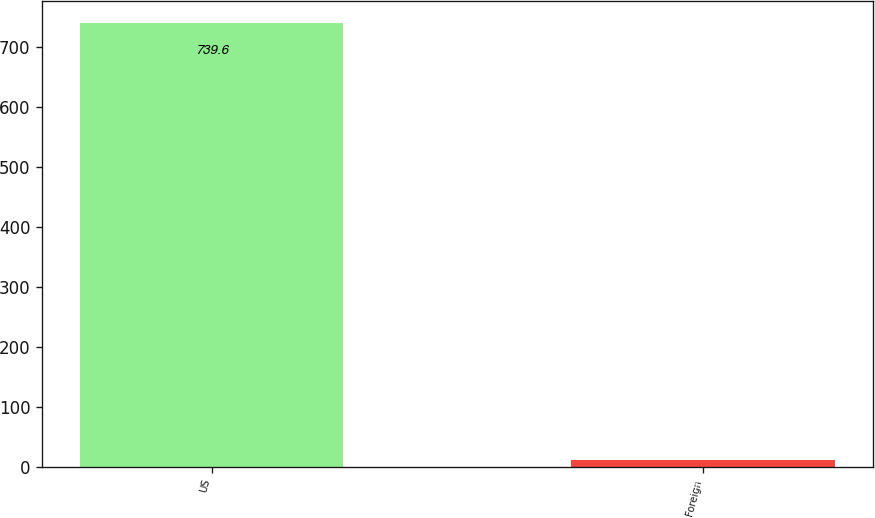Convert chart to OTSL. <chart><loc_0><loc_0><loc_500><loc_500><bar_chart><fcel>US<fcel>Foreign<nl><fcel>739.6<fcel>11.4<nl></chart> 